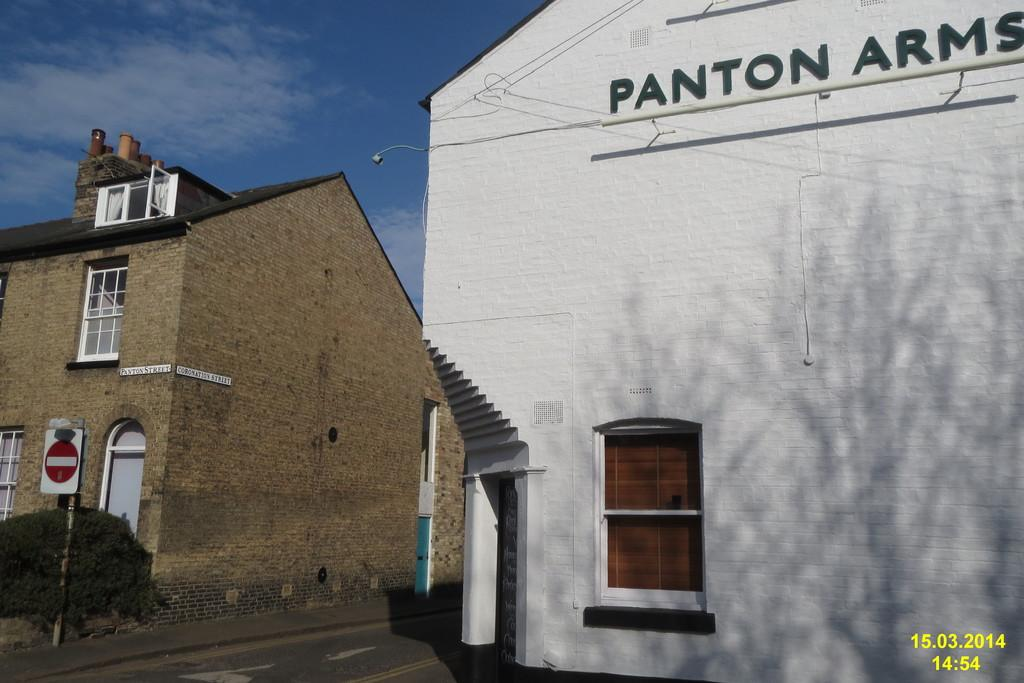<image>
Give a short and clear explanation of the subsequent image. A white building says Panton Arms in dark letters. 